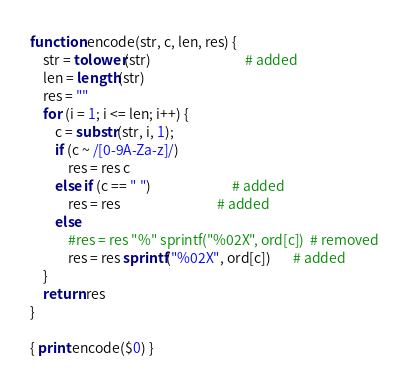Convert code to text. <code><loc_0><loc_0><loc_500><loc_500><_Awk_>
function encode(str, c, len, res) {
    str = tolower(str)                              # added
    len = length(str)
    res = ""
    for (i = 1; i <= len; i++) {
        c = substr(str, i, 1);
        if (c ~ /[0-9A-Za-z]/)
            res = res c
        else if (c == " ")                          # added
            res = res                               # added
        else
            #res = res "%" sprintf("%02X", ord[c])  # removed
            res = res sprintf("%02X", ord[c])       # added
    }
    return res
}

{ print encode($0) }
</code> 